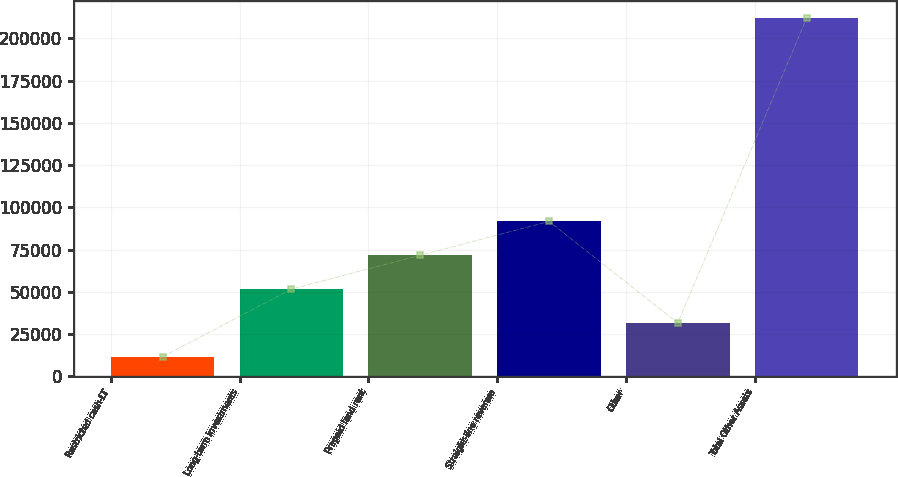Convert chart. <chart><loc_0><loc_0><loc_500><loc_500><bar_chart><fcel>Restricted cash-LT<fcel>Long-term investments<fcel>Prepaid land rent<fcel>Straight-line revenue<fcel>Other<fcel>Total Other Assets<nl><fcel>11495<fcel>51556.4<fcel>71587.1<fcel>91617.8<fcel>31525.7<fcel>211802<nl></chart> 